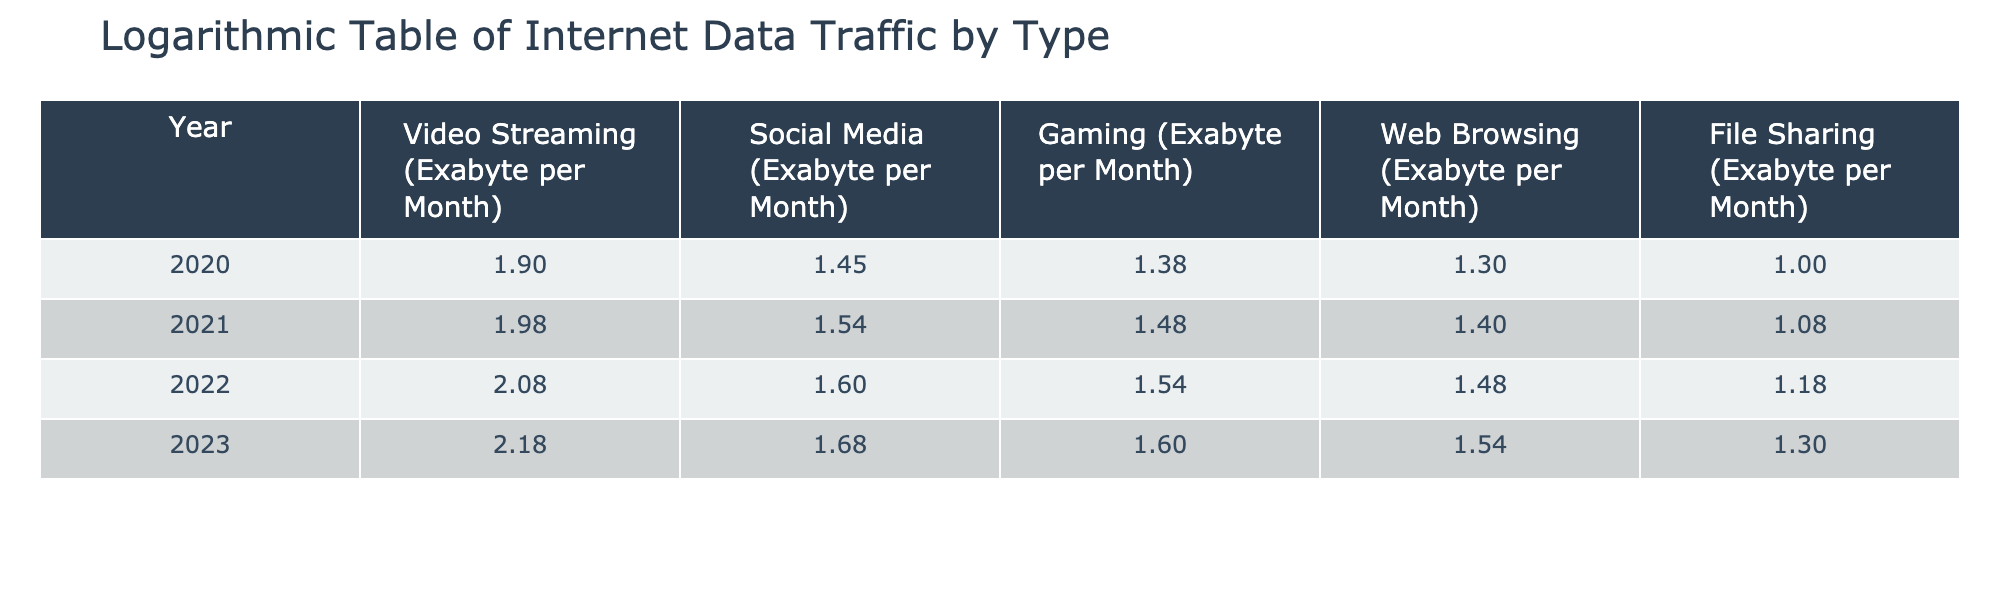What is the logarithmic value for Video Streaming in 2022? The logarithmic value for a category is obtained by referencing the corresponding value from the table for that year. Looking at the row for 2022, the value for Video Streaming is 120 Exabyte per Month. Taking the logarithm base 10 gives us log10(120) ≈ 2.08.
Answer: 2.08 Which type of internet data traffic had the highest logarithmic value in 2023? To determine this, we review the logarithmic values for each type in 2023. The values are: Video Streaming (log10(150) ≈ 2.18), Social Media (log10(48) ≈ 1.68), Gaming (log10(40) ≈ 1.60), Web Browsing (log10(35) ≈ 1.54), and File Sharing (log10(20) ≈ 1.30). The highest value is for Video Streaming, which is approximately 2.18.
Answer: Video Streaming What is the difference in logarithmic values for Social Media between 2020 and 2023? The logarithmic value for Social Media in 2020 is log10(28) ≈ 1.45, and in 2023 it is log10(48) ≈ 1.68. To find the difference, we subtract the two values: 1.68 - 1.45 ≈ 0.23.
Answer: 0.23 Is the logarithmic value for Gaming in 2021 greater than that for Web Browsing in 2022? First, we find the logarithmic value for Gaming in 2021, which is log10(30) ≈ 1.48. Next, we find the value for Web Browsing in 2022, which is log10(30) ≈ 1.48. Since 1.48 is equal in both cases, the statement is false.
Answer: No What is the average logarithmic value of all types of internet data traffic in 2022? To find the average, we first gather the logarithmic values for 2022: Video Streaming (log10(120) ≈ 2.08), Social Media (log10(40) ≈ 1.60), Gaming (log10(35) ≈ 1.54), Web Browsing (log10(30) ≈ 1.48), and File Sharing (log10(15) ≈ 1.18). The sum of these values is 2.08 + 1.60 + 1.54 + 1.48 + 1.18 = 7.88. We divide this sum by the number of categories (5): 7.88 / 5 ≈ 1.576.
Answer: 1.576 Which year showed the largest increase in logarithmic value for Video Streaming compared to the previous year? We will calculate the difference in logarithmic values for Video Streaming between consecutive years: 2020 to 2021: log10(95) - log10(80) ≈ 1.98 - 1.90 = 0.08; 2021 to 2022: log10(120) - log10(95) ≈ 2.08 - 1.98 = 0.10; 2022 to 2023: log10(150) - log10(120) ≈ 2.18 - 2.08 = 0.10. The largest increase occurred from 2021 to 2022, which is 0.10.
Answer: 0.10 